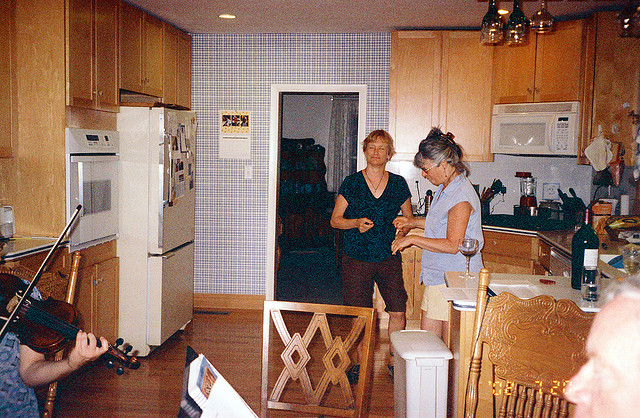What instrument is being played?
Answer the question using a single word or phrase. Violin 